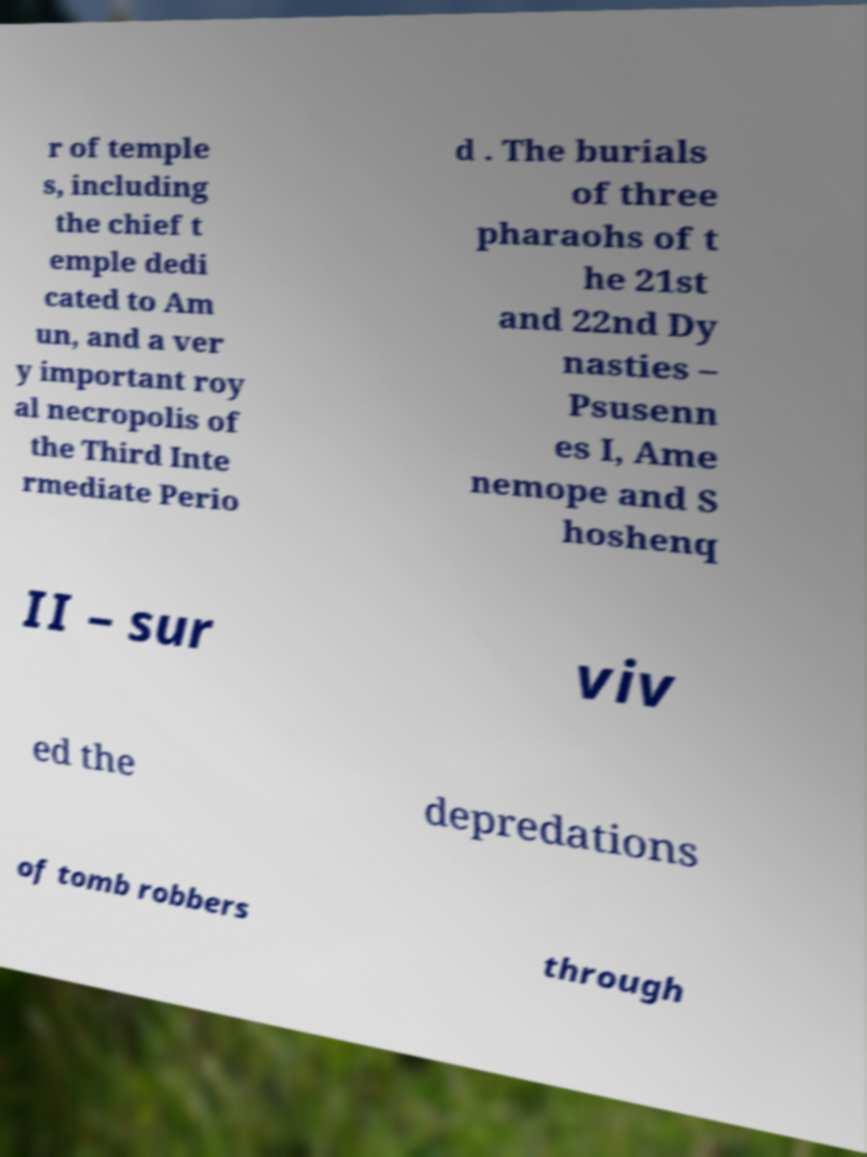There's text embedded in this image that I need extracted. Can you transcribe it verbatim? r of temple s, including the chief t emple dedi cated to Am un, and a ver y important roy al necropolis of the Third Inte rmediate Perio d . The burials of three pharaohs of t he 21st and 22nd Dy nasties – Psusenn es I, Ame nemope and S hoshenq II – sur viv ed the depredations of tomb robbers through 